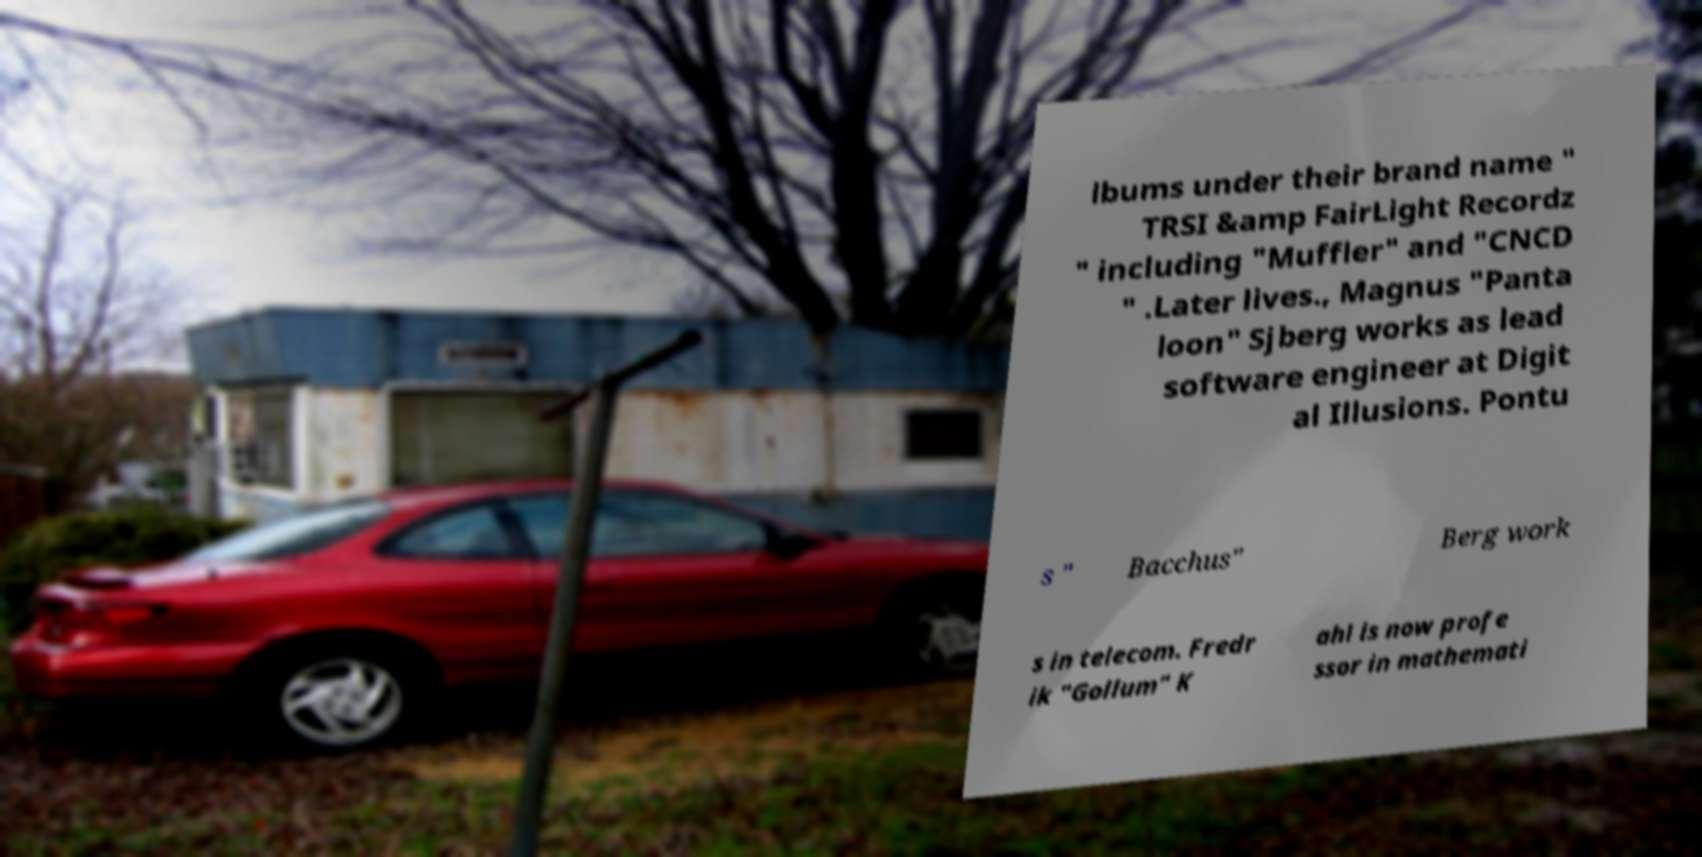What messages or text are displayed in this image? I need them in a readable, typed format. lbums under their brand name " TRSI &amp FairLight Recordz " including "Muffler" and "CNCD " .Later lives., Magnus "Panta loon" Sjberg works as lead software engineer at Digit al Illusions. Pontu s " Bacchus" Berg work s in telecom. Fredr ik "Gollum" K ahl is now profe ssor in mathemati 